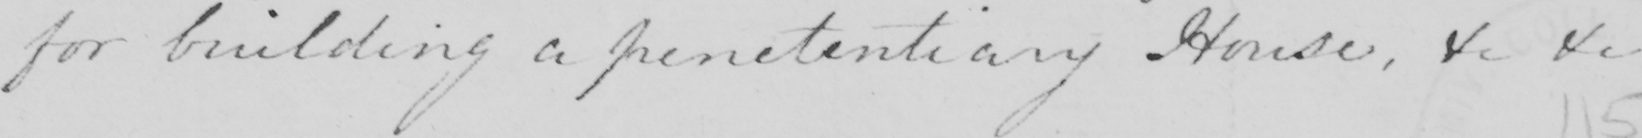Please provide the text content of this handwritten line. for building a penetentiary House , &c &c  _ 